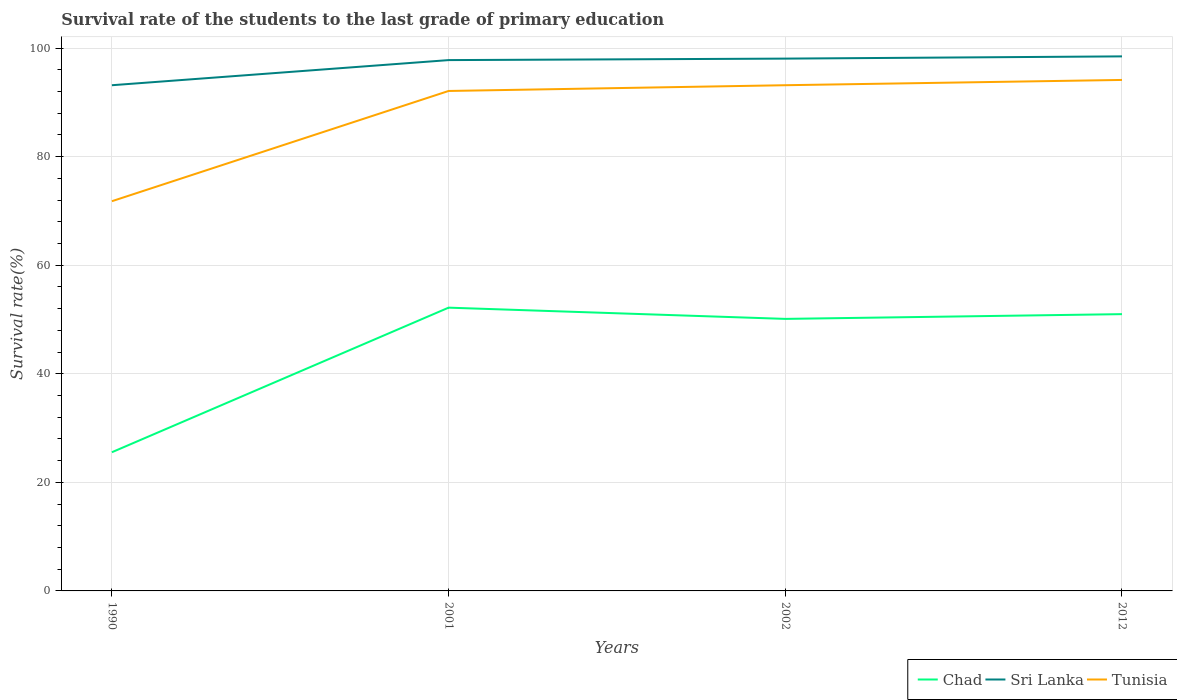How many different coloured lines are there?
Provide a short and direct response. 3. Does the line corresponding to Tunisia intersect with the line corresponding to Chad?
Ensure brevity in your answer.  No. Across all years, what is the maximum survival rate of the students in Tunisia?
Your answer should be very brief. 71.79. What is the total survival rate of the students in Chad in the graph?
Keep it short and to the point. -26.64. What is the difference between the highest and the second highest survival rate of the students in Tunisia?
Provide a succinct answer. 22.34. What is the difference between the highest and the lowest survival rate of the students in Chad?
Your response must be concise. 3. Is the survival rate of the students in Chad strictly greater than the survival rate of the students in Sri Lanka over the years?
Provide a short and direct response. Yes. Are the values on the major ticks of Y-axis written in scientific E-notation?
Provide a short and direct response. No. Does the graph contain any zero values?
Give a very brief answer. No. Does the graph contain grids?
Make the answer very short. Yes. How many legend labels are there?
Provide a short and direct response. 3. How are the legend labels stacked?
Offer a very short reply. Horizontal. What is the title of the graph?
Offer a very short reply. Survival rate of the students to the last grade of primary education. Does "Luxembourg" appear as one of the legend labels in the graph?
Make the answer very short. No. What is the label or title of the X-axis?
Your response must be concise. Years. What is the label or title of the Y-axis?
Provide a short and direct response. Survival rate(%). What is the Survival rate(%) of Chad in 1990?
Your answer should be compact. 25.55. What is the Survival rate(%) of Sri Lanka in 1990?
Keep it short and to the point. 93.16. What is the Survival rate(%) of Tunisia in 1990?
Give a very brief answer. 71.79. What is the Survival rate(%) in Chad in 2001?
Give a very brief answer. 52.18. What is the Survival rate(%) of Sri Lanka in 2001?
Make the answer very short. 97.79. What is the Survival rate(%) in Tunisia in 2001?
Provide a short and direct response. 92.1. What is the Survival rate(%) of Chad in 2002?
Provide a short and direct response. 50.11. What is the Survival rate(%) in Sri Lanka in 2002?
Keep it short and to the point. 98.06. What is the Survival rate(%) in Tunisia in 2002?
Provide a short and direct response. 93.16. What is the Survival rate(%) of Chad in 2012?
Your answer should be compact. 50.99. What is the Survival rate(%) of Sri Lanka in 2012?
Offer a very short reply. 98.47. What is the Survival rate(%) of Tunisia in 2012?
Provide a short and direct response. 94.13. Across all years, what is the maximum Survival rate(%) in Chad?
Offer a terse response. 52.18. Across all years, what is the maximum Survival rate(%) in Sri Lanka?
Make the answer very short. 98.47. Across all years, what is the maximum Survival rate(%) of Tunisia?
Your answer should be compact. 94.13. Across all years, what is the minimum Survival rate(%) in Chad?
Provide a short and direct response. 25.55. Across all years, what is the minimum Survival rate(%) of Sri Lanka?
Provide a succinct answer. 93.16. Across all years, what is the minimum Survival rate(%) of Tunisia?
Offer a very short reply. 71.79. What is the total Survival rate(%) of Chad in the graph?
Give a very brief answer. 178.83. What is the total Survival rate(%) in Sri Lanka in the graph?
Your response must be concise. 387.47. What is the total Survival rate(%) in Tunisia in the graph?
Offer a terse response. 351.18. What is the difference between the Survival rate(%) in Chad in 1990 and that in 2001?
Your answer should be very brief. -26.64. What is the difference between the Survival rate(%) in Sri Lanka in 1990 and that in 2001?
Make the answer very short. -4.63. What is the difference between the Survival rate(%) of Tunisia in 1990 and that in 2001?
Offer a terse response. -20.31. What is the difference between the Survival rate(%) of Chad in 1990 and that in 2002?
Offer a very short reply. -24.56. What is the difference between the Survival rate(%) in Sri Lanka in 1990 and that in 2002?
Provide a succinct answer. -4.9. What is the difference between the Survival rate(%) in Tunisia in 1990 and that in 2002?
Your answer should be compact. -21.37. What is the difference between the Survival rate(%) in Chad in 1990 and that in 2012?
Your answer should be compact. -25.44. What is the difference between the Survival rate(%) of Sri Lanka in 1990 and that in 2012?
Keep it short and to the point. -5.32. What is the difference between the Survival rate(%) in Tunisia in 1990 and that in 2012?
Your response must be concise. -22.34. What is the difference between the Survival rate(%) of Chad in 2001 and that in 2002?
Keep it short and to the point. 2.07. What is the difference between the Survival rate(%) in Sri Lanka in 2001 and that in 2002?
Ensure brevity in your answer.  -0.28. What is the difference between the Survival rate(%) in Tunisia in 2001 and that in 2002?
Make the answer very short. -1.06. What is the difference between the Survival rate(%) in Chad in 2001 and that in 2012?
Offer a terse response. 1.2. What is the difference between the Survival rate(%) of Sri Lanka in 2001 and that in 2012?
Keep it short and to the point. -0.69. What is the difference between the Survival rate(%) of Tunisia in 2001 and that in 2012?
Provide a short and direct response. -2.03. What is the difference between the Survival rate(%) in Chad in 2002 and that in 2012?
Ensure brevity in your answer.  -0.88. What is the difference between the Survival rate(%) of Sri Lanka in 2002 and that in 2012?
Ensure brevity in your answer.  -0.41. What is the difference between the Survival rate(%) of Tunisia in 2002 and that in 2012?
Offer a very short reply. -0.97. What is the difference between the Survival rate(%) in Chad in 1990 and the Survival rate(%) in Sri Lanka in 2001?
Make the answer very short. -72.24. What is the difference between the Survival rate(%) in Chad in 1990 and the Survival rate(%) in Tunisia in 2001?
Ensure brevity in your answer.  -66.55. What is the difference between the Survival rate(%) in Sri Lanka in 1990 and the Survival rate(%) in Tunisia in 2001?
Provide a short and direct response. 1.06. What is the difference between the Survival rate(%) in Chad in 1990 and the Survival rate(%) in Sri Lanka in 2002?
Give a very brief answer. -72.51. What is the difference between the Survival rate(%) in Chad in 1990 and the Survival rate(%) in Tunisia in 2002?
Your answer should be very brief. -67.61. What is the difference between the Survival rate(%) of Sri Lanka in 1990 and the Survival rate(%) of Tunisia in 2002?
Make the answer very short. -0. What is the difference between the Survival rate(%) of Chad in 1990 and the Survival rate(%) of Sri Lanka in 2012?
Give a very brief answer. -72.92. What is the difference between the Survival rate(%) in Chad in 1990 and the Survival rate(%) in Tunisia in 2012?
Offer a terse response. -68.58. What is the difference between the Survival rate(%) in Sri Lanka in 1990 and the Survival rate(%) in Tunisia in 2012?
Provide a short and direct response. -0.97. What is the difference between the Survival rate(%) of Chad in 2001 and the Survival rate(%) of Sri Lanka in 2002?
Offer a terse response. -45.88. What is the difference between the Survival rate(%) of Chad in 2001 and the Survival rate(%) of Tunisia in 2002?
Your response must be concise. -40.98. What is the difference between the Survival rate(%) of Sri Lanka in 2001 and the Survival rate(%) of Tunisia in 2002?
Give a very brief answer. 4.63. What is the difference between the Survival rate(%) in Chad in 2001 and the Survival rate(%) in Sri Lanka in 2012?
Ensure brevity in your answer.  -46.29. What is the difference between the Survival rate(%) of Chad in 2001 and the Survival rate(%) of Tunisia in 2012?
Your answer should be very brief. -41.95. What is the difference between the Survival rate(%) in Sri Lanka in 2001 and the Survival rate(%) in Tunisia in 2012?
Give a very brief answer. 3.65. What is the difference between the Survival rate(%) in Chad in 2002 and the Survival rate(%) in Sri Lanka in 2012?
Your answer should be very brief. -48.36. What is the difference between the Survival rate(%) in Chad in 2002 and the Survival rate(%) in Tunisia in 2012?
Your response must be concise. -44.02. What is the difference between the Survival rate(%) of Sri Lanka in 2002 and the Survival rate(%) of Tunisia in 2012?
Your answer should be very brief. 3.93. What is the average Survival rate(%) in Chad per year?
Give a very brief answer. 44.71. What is the average Survival rate(%) of Sri Lanka per year?
Provide a short and direct response. 96.87. What is the average Survival rate(%) in Tunisia per year?
Provide a succinct answer. 87.8. In the year 1990, what is the difference between the Survival rate(%) in Chad and Survival rate(%) in Sri Lanka?
Ensure brevity in your answer.  -67.61. In the year 1990, what is the difference between the Survival rate(%) of Chad and Survival rate(%) of Tunisia?
Offer a very short reply. -46.24. In the year 1990, what is the difference between the Survival rate(%) of Sri Lanka and Survival rate(%) of Tunisia?
Offer a terse response. 21.36. In the year 2001, what is the difference between the Survival rate(%) in Chad and Survival rate(%) in Sri Lanka?
Provide a succinct answer. -45.6. In the year 2001, what is the difference between the Survival rate(%) in Chad and Survival rate(%) in Tunisia?
Provide a short and direct response. -39.92. In the year 2001, what is the difference between the Survival rate(%) of Sri Lanka and Survival rate(%) of Tunisia?
Keep it short and to the point. 5.69. In the year 2002, what is the difference between the Survival rate(%) in Chad and Survival rate(%) in Sri Lanka?
Provide a succinct answer. -47.95. In the year 2002, what is the difference between the Survival rate(%) in Chad and Survival rate(%) in Tunisia?
Provide a succinct answer. -43.05. In the year 2002, what is the difference between the Survival rate(%) of Sri Lanka and Survival rate(%) of Tunisia?
Offer a terse response. 4.9. In the year 2012, what is the difference between the Survival rate(%) in Chad and Survival rate(%) in Sri Lanka?
Keep it short and to the point. -47.48. In the year 2012, what is the difference between the Survival rate(%) in Chad and Survival rate(%) in Tunisia?
Ensure brevity in your answer.  -43.14. In the year 2012, what is the difference between the Survival rate(%) in Sri Lanka and Survival rate(%) in Tunisia?
Make the answer very short. 4.34. What is the ratio of the Survival rate(%) in Chad in 1990 to that in 2001?
Ensure brevity in your answer.  0.49. What is the ratio of the Survival rate(%) of Sri Lanka in 1990 to that in 2001?
Keep it short and to the point. 0.95. What is the ratio of the Survival rate(%) of Tunisia in 1990 to that in 2001?
Give a very brief answer. 0.78. What is the ratio of the Survival rate(%) in Chad in 1990 to that in 2002?
Offer a very short reply. 0.51. What is the ratio of the Survival rate(%) of Tunisia in 1990 to that in 2002?
Make the answer very short. 0.77. What is the ratio of the Survival rate(%) in Chad in 1990 to that in 2012?
Your response must be concise. 0.5. What is the ratio of the Survival rate(%) of Sri Lanka in 1990 to that in 2012?
Your answer should be very brief. 0.95. What is the ratio of the Survival rate(%) in Tunisia in 1990 to that in 2012?
Your answer should be very brief. 0.76. What is the ratio of the Survival rate(%) of Chad in 2001 to that in 2002?
Offer a very short reply. 1.04. What is the ratio of the Survival rate(%) in Sri Lanka in 2001 to that in 2002?
Keep it short and to the point. 1. What is the ratio of the Survival rate(%) of Chad in 2001 to that in 2012?
Your response must be concise. 1.02. What is the ratio of the Survival rate(%) in Tunisia in 2001 to that in 2012?
Give a very brief answer. 0.98. What is the ratio of the Survival rate(%) of Chad in 2002 to that in 2012?
Your answer should be compact. 0.98. What is the ratio of the Survival rate(%) in Tunisia in 2002 to that in 2012?
Your answer should be very brief. 0.99. What is the difference between the highest and the second highest Survival rate(%) of Chad?
Provide a succinct answer. 1.2. What is the difference between the highest and the second highest Survival rate(%) in Sri Lanka?
Your answer should be very brief. 0.41. What is the difference between the highest and the second highest Survival rate(%) of Tunisia?
Your response must be concise. 0.97. What is the difference between the highest and the lowest Survival rate(%) in Chad?
Offer a very short reply. 26.64. What is the difference between the highest and the lowest Survival rate(%) in Sri Lanka?
Offer a very short reply. 5.32. What is the difference between the highest and the lowest Survival rate(%) of Tunisia?
Your answer should be compact. 22.34. 